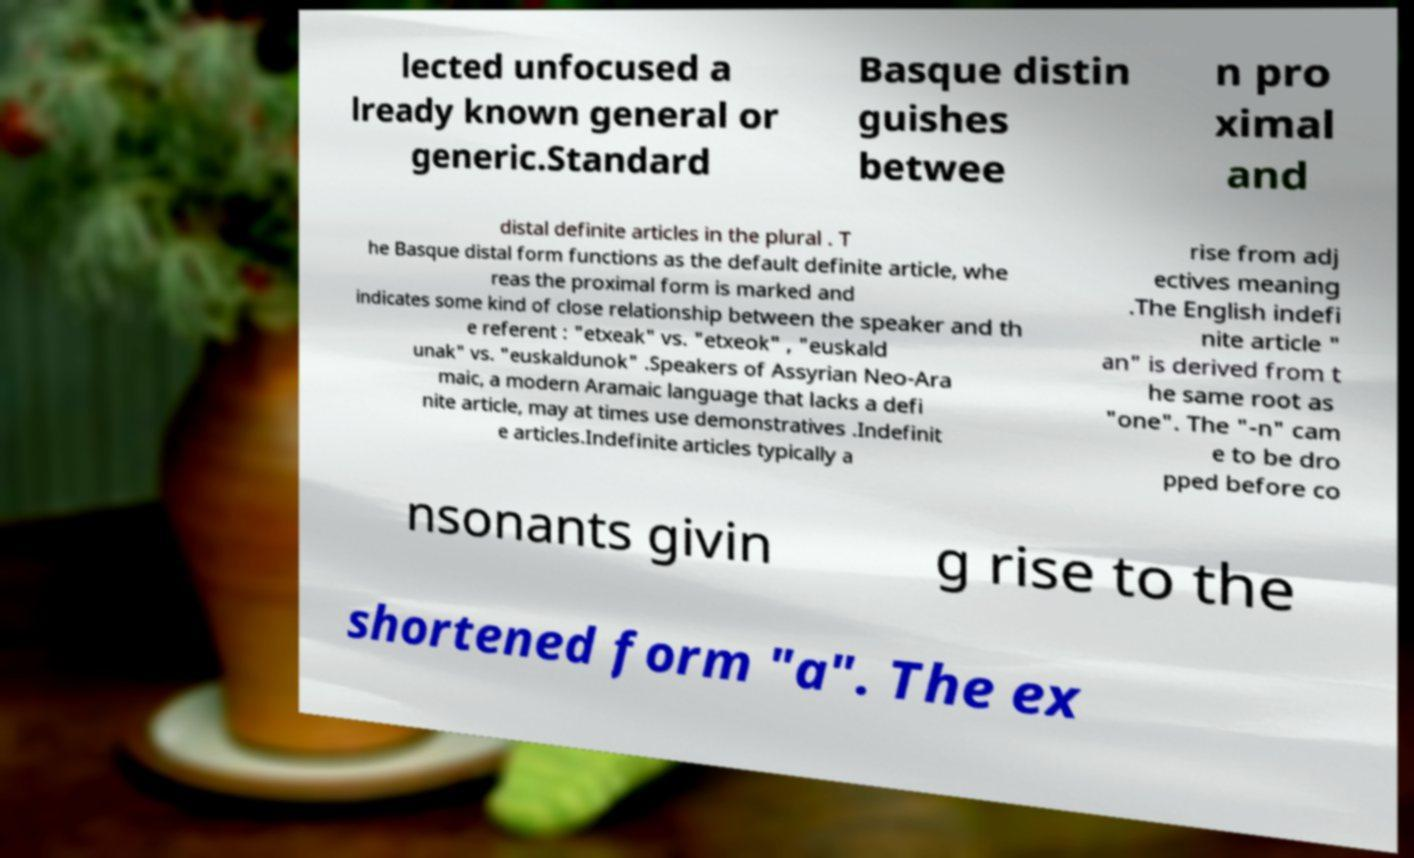Can you read and provide the text displayed in the image?This photo seems to have some interesting text. Can you extract and type it out for me? lected unfocused a lready known general or generic.Standard Basque distin guishes betwee n pro ximal and distal definite articles in the plural . T he Basque distal form functions as the default definite article, whe reas the proximal form is marked and indicates some kind of close relationship between the speaker and th e referent : "etxeak" vs. "etxeok" , "euskald unak" vs. "euskaldunok" .Speakers of Assyrian Neo-Ara maic, a modern Aramaic language that lacks a defi nite article, may at times use demonstratives .Indefinit e articles.Indefinite articles typically a rise from adj ectives meaning .The English indefi nite article " an" is derived from t he same root as "one". The "-n" cam e to be dro pped before co nsonants givin g rise to the shortened form "a". The ex 